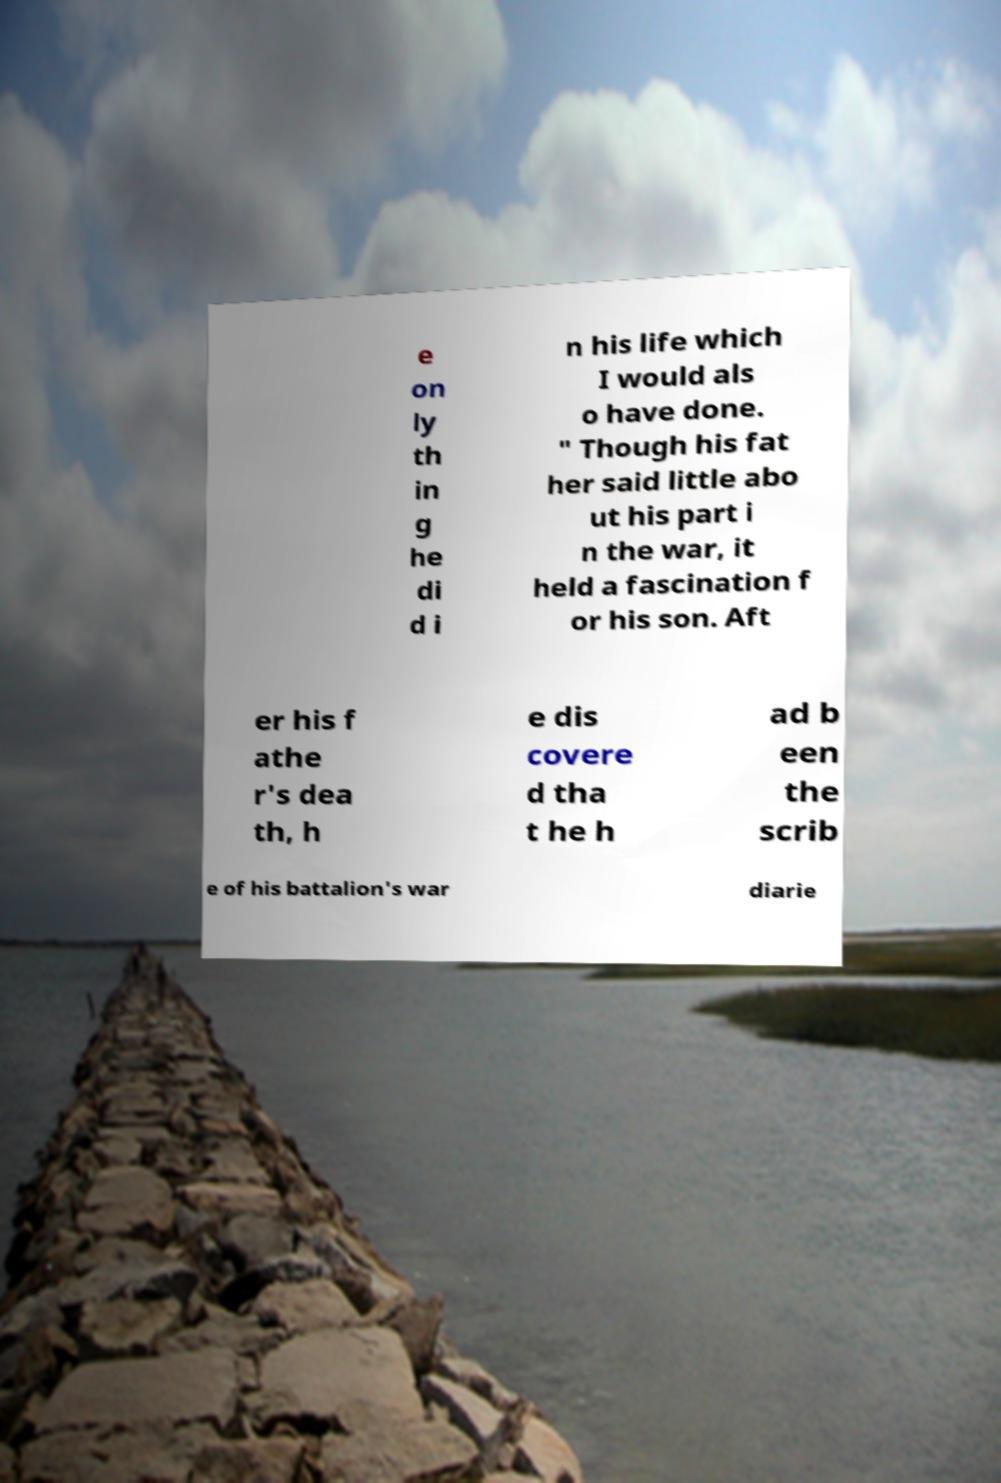For documentation purposes, I need the text within this image transcribed. Could you provide that? e on ly th in g he di d i n his life which I would als o have done. " Though his fat her said little abo ut his part i n the war, it held a fascination f or his son. Aft er his f athe r's dea th, h e dis covere d tha t he h ad b een the scrib e of his battalion's war diarie 